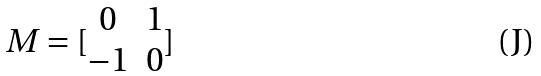<formula> <loc_0><loc_0><loc_500><loc_500>M = [ \begin{matrix} 0 & 1 \\ - 1 & 0 \end{matrix} ]</formula> 